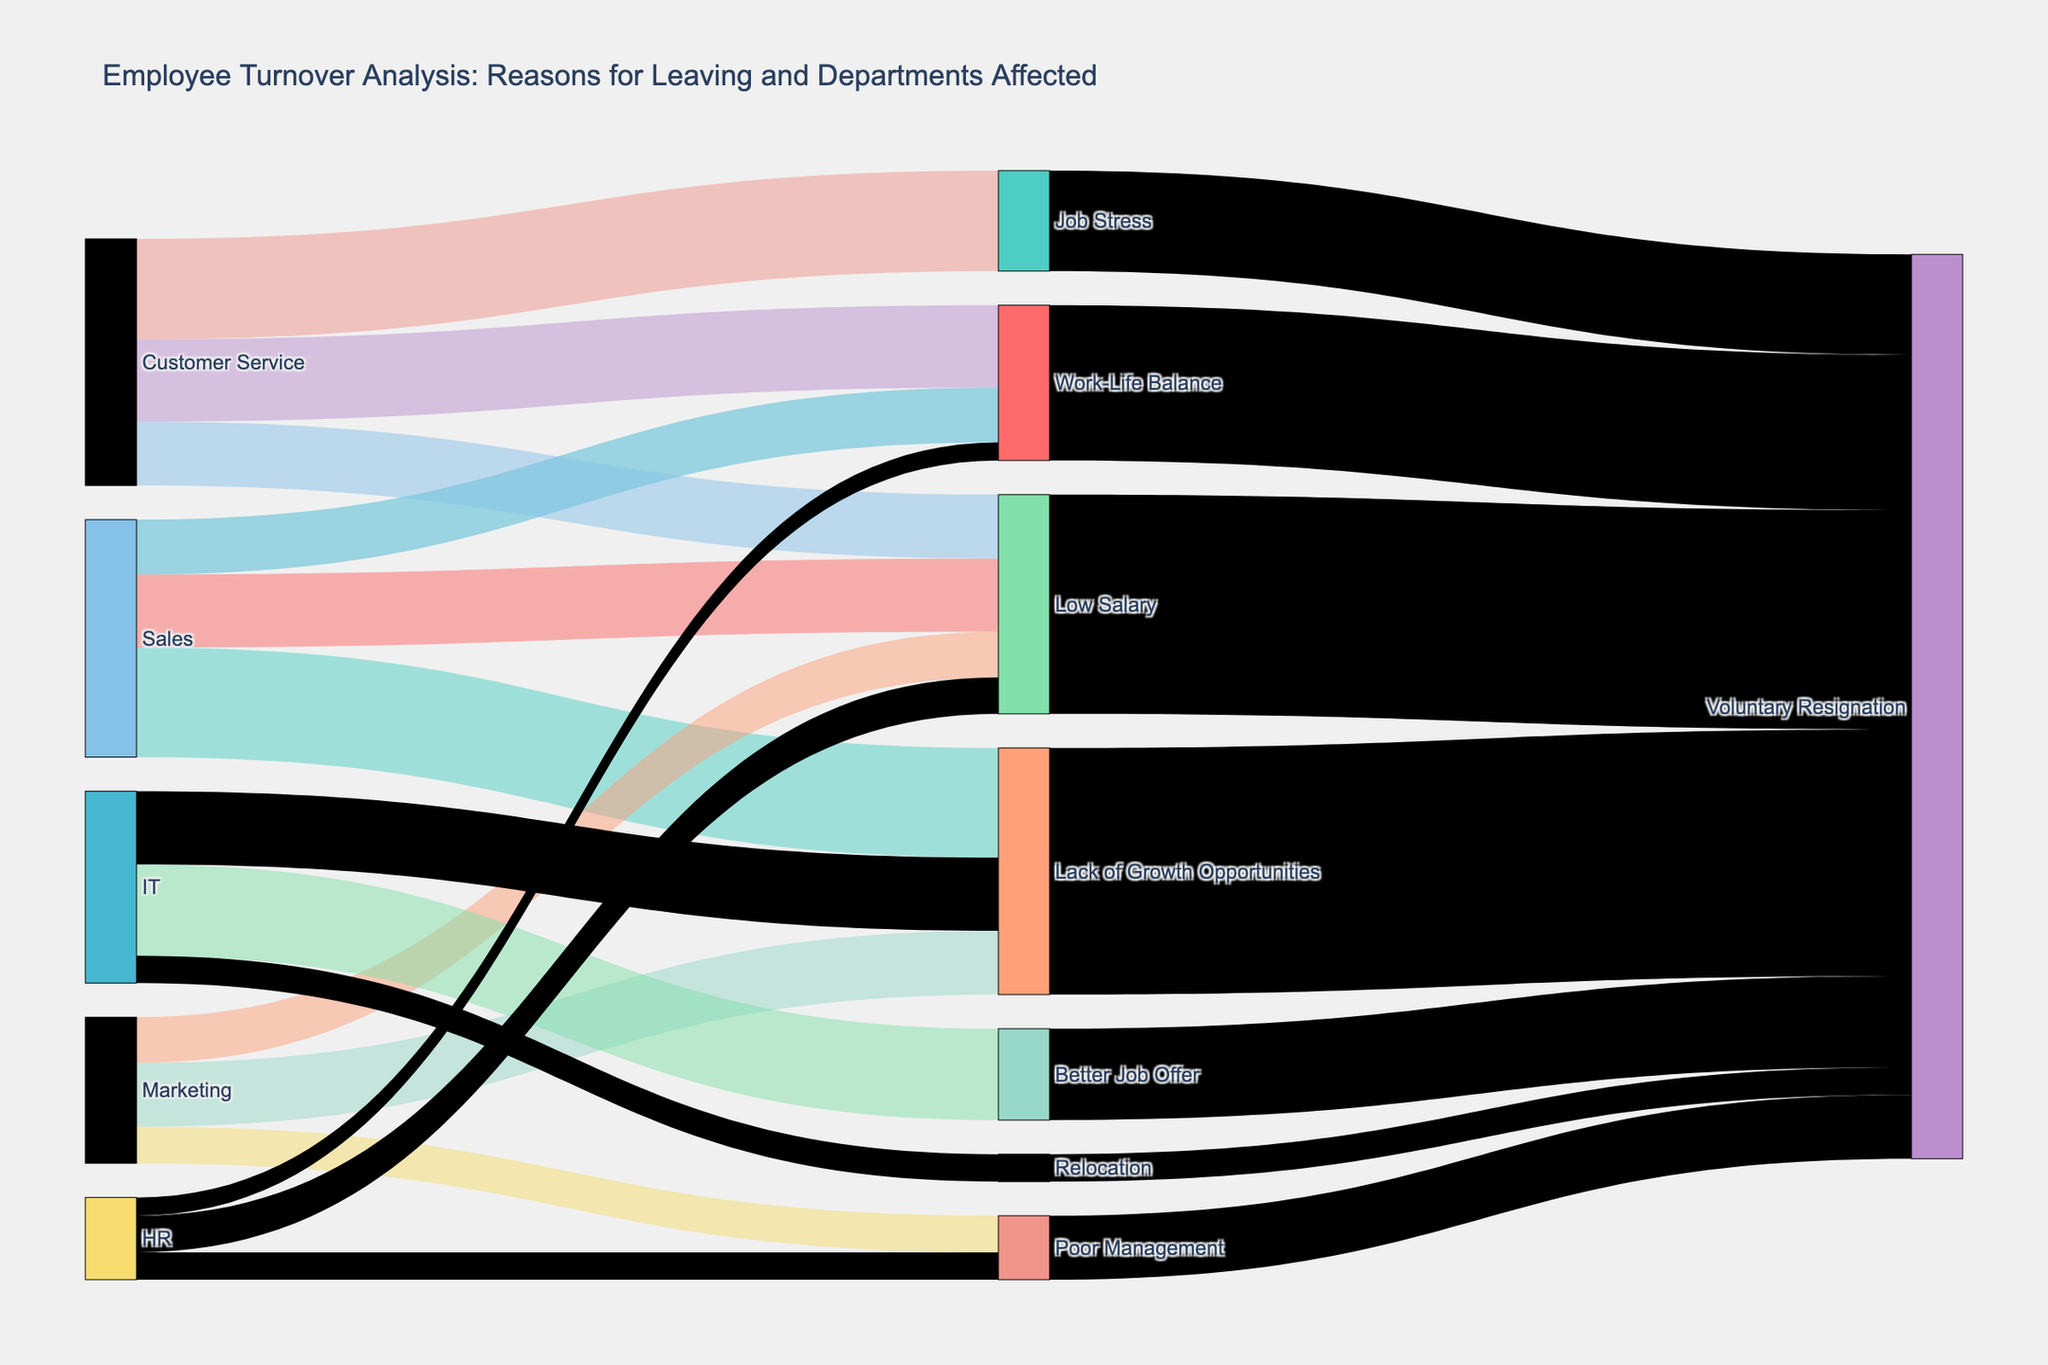Which department has the highest number of employees leaving due to low salary? The Sankey diagram shows the flows from different departments to reasons for leaving. The flow from "Sales" to "Low Salary" has the highest value of 8 compared to other departments.
Answer: Sales What is the total number of employees who left due to Lack of Growth Opportunities across all departments? Adding the values flowing into "Lack of Growth Opportunities," we have 12 from Sales, 7 from Marketing, and 8 from IT. Summing these values: 12 + 7 + 8 = 27.
Answer: 27 Which reason for leaving affects the Customer Service department the most? By observing the arrows originating from "Customer Service," the one leading to "Job Stress" has the highest value at 11.
Answer: Job Stress How many employees left the IT department due to Better Job Offers and Relocation combined? Summing the values flowing from IT to "Better Job Offer" (10) and "Relocation" (3), we get 10 + 3 = 13.
Answer: 13 Which reason for leaving results in the highest number of Voluntary Resignations? Examining the flows into "Voluntary Resignation," "Lack of Growth Opportunities" has the highest value of 27.
Answer: Lack of Growth Opportunities Compare the number of employees leaving due to Poor Management in Marketing and HR. In the Sankey diagram, Marketing's flow to "Poor Management" is 4, and HR's flow to "Poor Management" is 3. Comparing these values, 4 is greater than 3.
Answer: Marketing has more employees leaving due to Poor Management What percentage of employees from the Customer Service department leave due to Work-Life Balance? For Customer Service, the total values for employees leaving are 9 (Work-Life Balance) + 11 (Job Stress) + 7 (Low Salary) = 27. The percentage leaving due to Work-Life Balance is (9 / 27) * 100 = 33.33%.
Answer: 33.33% Which department has the least number of employees leaving, and for which reason? Looking at the flows, HR has the smallest flow at 2 for "Work-Life Balance."
Answer: HR for Work-Life Balance How many employees leave the company due to Voluntary Resignation as a result of Low Salary? The arrow from "Low Salary" to "Voluntary Resignation" has a value of 24.
Answer: 24 